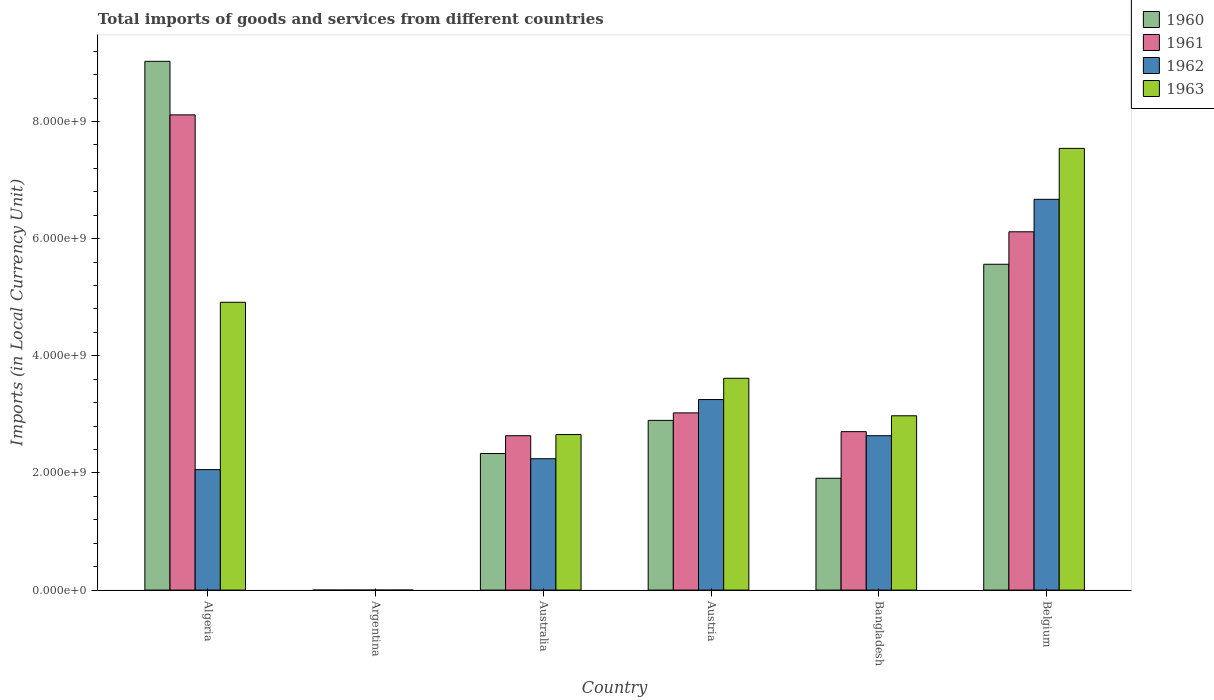How many different coloured bars are there?
Ensure brevity in your answer.  4. Are the number of bars per tick equal to the number of legend labels?
Provide a succinct answer. Yes. Are the number of bars on each tick of the X-axis equal?
Your response must be concise. Yes. How many bars are there on the 5th tick from the left?
Make the answer very short. 4. What is the label of the 3rd group of bars from the left?
Your answer should be compact. Australia. In how many cases, is the number of bars for a given country not equal to the number of legend labels?
Make the answer very short. 0. What is the Amount of goods and services imports in 1960 in Australia?
Offer a terse response. 2.33e+09. Across all countries, what is the maximum Amount of goods and services imports in 1961?
Ensure brevity in your answer.  8.11e+09. Across all countries, what is the minimum Amount of goods and services imports in 1960?
Provide a succinct answer. 0.01. In which country was the Amount of goods and services imports in 1960 maximum?
Ensure brevity in your answer.  Algeria. What is the total Amount of goods and services imports in 1963 in the graph?
Provide a succinct answer. 2.17e+1. What is the difference between the Amount of goods and services imports in 1962 in Argentina and that in Australia?
Your response must be concise. -2.24e+09. What is the difference between the Amount of goods and services imports in 1963 in Belgium and the Amount of goods and services imports in 1962 in Argentina?
Give a very brief answer. 7.54e+09. What is the average Amount of goods and services imports in 1960 per country?
Your answer should be compact. 3.62e+09. What is the difference between the Amount of goods and services imports of/in 1961 and Amount of goods and services imports of/in 1963 in Belgium?
Offer a terse response. -1.42e+09. What is the ratio of the Amount of goods and services imports in 1963 in Argentina to that in Australia?
Your answer should be very brief. 7.530120331325301e-12. What is the difference between the highest and the second highest Amount of goods and services imports in 1961?
Provide a succinct answer. 2.00e+09. What is the difference between the highest and the lowest Amount of goods and services imports in 1963?
Ensure brevity in your answer.  7.54e+09. In how many countries, is the Amount of goods and services imports in 1960 greater than the average Amount of goods and services imports in 1960 taken over all countries?
Your answer should be very brief. 2. Is it the case that in every country, the sum of the Amount of goods and services imports in 1963 and Amount of goods and services imports in 1961 is greater than the sum of Amount of goods and services imports in 1962 and Amount of goods and services imports in 1960?
Your answer should be very brief. No. What does the 3rd bar from the left in Australia represents?
Make the answer very short. 1962. How many bars are there?
Your response must be concise. 24. How many countries are there in the graph?
Provide a succinct answer. 6. What is the difference between two consecutive major ticks on the Y-axis?
Ensure brevity in your answer.  2.00e+09. Does the graph contain grids?
Your answer should be very brief. No. How many legend labels are there?
Offer a terse response. 4. How are the legend labels stacked?
Provide a succinct answer. Vertical. What is the title of the graph?
Your answer should be compact. Total imports of goods and services from different countries. Does "1996" appear as one of the legend labels in the graph?
Your answer should be very brief. No. What is the label or title of the X-axis?
Provide a short and direct response. Country. What is the label or title of the Y-axis?
Your response must be concise. Imports (in Local Currency Unit). What is the Imports (in Local Currency Unit) in 1960 in Algeria?
Offer a very short reply. 9.03e+09. What is the Imports (in Local Currency Unit) in 1961 in Algeria?
Provide a succinct answer. 8.11e+09. What is the Imports (in Local Currency Unit) of 1962 in Algeria?
Keep it short and to the point. 2.06e+09. What is the Imports (in Local Currency Unit) of 1963 in Algeria?
Keep it short and to the point. 4.91e+09. What is the Imports (in Local Currency Unit) in 1960 in Argentina?
Give a very brief answer. 0.01. What is the Imports (in Local Currency Unit) of 1961 in Argentina?
Provide a succinct answer. 0.01. What is the Imports (in Local Currency Unit) of 1962 in Argentina?
Keep it short and to the point. 0.02. What is the Imports (in Local Currency Unit) of 1963 in Argentina?
Keep it short and to the point. 0.02. What is the Imports (in Local Currency Unit) in 1960 in Australia?
Your answer should be compact. 2.33e+09. What is the Imports (in Local Currency Unit) in 1961 in Australia?
Make the answer very short. 2.64e+09. What is the Imports (in Local Currency Unit) in 1962 in Australia?
Give a very brief answer. 2.24e+09. What is the Imports (in Local Currency Unit) of 1963 in Australia?
Keep it short and to the point. 2.66e+09. What is the Imports (in Local Currency Unit) in 1960 in Austria?
Give a very brief answer. 2.90e+09. What is the Imports (in Local Currency Unit) of 1961 in Austria?
Your answer should be very brief. 3.03e+09. What is the Imports (in Local Currency Unit) of 1962 in Austria?
Your answer should be very brief. 3.25e+09. What is the Imports (in Local Currency Unit) of 1963 in Austria?
Your answer should be very brief. 3.62e+09. What is the Imports (in Local Currency Unit) in 1960 in Bangladesh?
Give a very brief answer. 1.91e+09. What is the Imports (in Local Currency Unit) in 1961 in Bangladesh?
Your response must be concise. 2.71e+09. What is the Imports (in Local Currency Unit) of 1962 in Bangladesh?
Provide a short and direct response. 2.64e+09. What is the Imports (in Local Currency Unit) in 1963 in Bangladesh?
Make the answer very short. 2.98e+09. What is the Imports (in Local Currency Unit) of 1960 in Belgium?
Make the answer very short. 5.56e+09. What is the Imports (in Local Currency Unit) in 1961 in Belgium?
Provide a short and direct response. 6.12e+09. What is the Imports (in Local Currency Unit) in 1962 in Belgium?
Offer a very short reply. 6.67e+09. What is the Imports (in Local Currency Unit) of 1963 in Belgium?
Ensure brevity in your answer.  7.54e+09. Across all countries, what is the maximum Imports (in Local Currency Unit) in 1960?
Keep it short and to the point. 9.03e+09. Across all countries, what is the maximum Imports (in Local Currency Unit) in 1961?
Offer a terse response. 8.11e+09. Across all countries, what is the maximum Imports (in Local Currency Unit) in 1962?
Your response must be concise. 6.67e+09. Across all countries, what is the maximum Imports (in Local Currency Unit) in 1963?
Keep it short and to the point. 7.54e+09. Across all countries, what is the minimum Imports (in Local Currency Unit) of 1960?
Make the answer very short. 0.01. Across all countries, what is the minimum Imports (in Local Currency Unit) of 1961?
Provide a short and direct response. 0.01. Across all countries, what is the minimum Imports (in Local Currency Unit) in 1962?
Offer a very short reply. 0.02. Across all countries, what is the minimum Imports (in Local Currency Unit) in 1963?
Provide a short and direct response. 0.02. What is the total Imports (in Local Currency Unit) in 1960 in the graph?
Provide a succinct answer. 2.17e+1. What is the total Imports (in Local Currency Unit) of 1961 in the graph?
Offer a terse response. 2.26e+1. What is the total Imports (in Local Currency Unit) of 1962 in the graph?
Give a very brief answer. 1.69e+1. What is the total Imports (in Local Currency Unit) of 1963 in the graph?
Make the answer very short. 2.17e+1. What is the difference between the Imports (in Local Currency Unit) in 1960 in Algeria and that in Argentina?
Keep it short and to the point. 9.03e+09. What is the difference between the Imports (in Local Currency Unit) of 1961 in Algeria and that in Argentina?
Offer a terse response. 8.11e+09. What is the difference between the Imports (in Local Currency Unit) of 1962 in Algeria and that in Argentina?
Provide a succinct answer. 2.06e+09. What is the difference between the Imports (in Local Currency Unit) of 1963 in Algeria and that in Argentina?
Offer a terse response. 4.91e+09. What is the difference between the Imports (in Local Currency Unit) of 1960 in Algeria and that in Australia?
Offer a terse response. 6.70e+09. What is the difference between the Imports (in Local Currency Unit) in 1961 in Algeria and that in Australia?
Your response must be concise. 5.48e+09. What is the difference between the Imports (in Local Currency Unit) of 1962 in Algeria and that in Australia?
Provide a short and direct response. -1.86e+08. What is the difference between the Imports (in Local Currency Unit) in 1963 in Algeria and that in Australia?
Make the answer very short. 2.26e+09. What is the difference between the Imports (in Local Currency Unit) in 1960 in Algeria and that in Austria?
Keep it short and to the point. 6.13e+09. What is the difference between the Imports (in Local Currency Unit) of 1961 in Algeria and that in Austria?
Make the answer very short. 5.09e+09. What is the difference between the Imports (in Local Currency Unit) in 1962 in Algeria and that in Austria?
Keep it short and to the point. -1.20e+09. What is the difference between the Imports (in Local Currency Unit) in 1963 in Algeria and that in Austria?
Make the answer very short. 1.30e+09. What is the difference between the Imports (in Local Currency Unit) in 1960 in Algeria and that in Bangladesh?
Provide a succinct answer. 7.12e+09. What is the difference between the Imports (in Local Currency Unit) in 1961 in Algeria and that in Bangladesh?
Provide a succinct answer. 5.41e+09. What is the difference between the Imports (in Local Currency Unit) of 1962 in Algeria and that in Bangladesh?
Make the answer very short. -5.79e+08. What is the difference between the Imports (in Local Currency Unit) in 1963 in Algeria and that in Bangladesh?
Your answer should be very brief. 1.94e+09. What is the difference between the Imports (in Local Currency Unit) of 1960 in Algeria and that in Belgium?
Ensure brevity in your answer.  3.46e+09. What is the difference between the Imports (in Local Currency Unit) of 1961 in Algeria and that in Belgium?
Offer a very short reply. 2.00e+09. What is the difference between the Imports (in Local Currency Unit) in 1962 in Algeria and that in Belgium?
Your answer should be compact. -4.62e+09. What is the difference between the Imports (in Local Currency Unit) in 1963 in Algeria and that in Belgium?
Provide a short and direct response. -2.63e+09. What is the difference between the Imports (in Local Currency Unit) of 1960 in Argentina and that in Australia?
Ensure brevity in your answer.  -2.33e+09. What is the difference between the Imports (in Local Currency Unit) of 1961 in Argentina and that in Australia?
Your response must be concise. -2.64e+09. What is the difference between the Imports (in Local Currency Unit) in 1962 in Argentina and that in Australia?
Offer a terse response. -2.24e+09. What is the difference between the Imports (in Local Currency Unit) of 1963 in Argentina and that in Australia?
Your answer should be compact. -2.66e+09. What is the difference between the Imports (in Local Currency Unit) of 1960 in Argentina and that in Austria?
Your answer should be compact. -2.90e+09. What is the difference between the Imports (in Local Currency Unit) of 1961 in Argentina and that in Austria?
Give a very brief answer. -3.03e+09. What is the difference between the Imports (in Local Currency Unit) of 1962 in Argentina and that in Austria?
Your response must be concise. -3.25e+09. What is the difference between the Imports (in Local Currency Unit) in 1963 in Argentina and that in Austria?
Provide a short and direct response. -3.62e+09. What is the difference between the Imports (in Local Currency Unit) in 1960 in Argentina and that in Bangladesh?
Provide a succinct answer. -1.91e+09. What is the difference between the Imports (in Local Currency Unit) in 1961 in Argentina and that in Bangladesh?
Offer a very short reply. -2.71e+09. What is the difference between the Imports (in Local Currency Unit) in 1962 in Argentina and that in Bangladesh?
Provide a succinct answer. -2.64e+09. What is the difference between the Imports (in Local Currency Unit) in 1963 in Argentina and that in Bangladesh?
Provide a succinct answer. -2.98e+09. What is the difference between the Imports (in Local Currency Unit) of 1960 in Argentina and that in Belgium?
Ensure brevity in your answer.  -5.56e+09. What is the difference between the Imports (in Local Currency Unit) in 1961 in Argentina and that in Belgium?
Your answer should be compact. -6.12e+09. What is the difference between the Imports (in Local Currency Unit) in 1962 in Argentina and that in Belgium?
Your answer should be very brief. -6.67e+09. What is the difference between the Imports (in Local Currency Unit) of 1963 in Argentina and that in Belgium?
Your response must be concise. -7.54e+09. What is the difference between the Imports (in Local Currency Unit) in 1960 in Australia and that in Austria?
Offer a terse response. -5.66e+08. What is the difference between the Imports (in Local Currency Unit) of 1961 in Australia and that in Austria?
Your answer should be compact. -3.90e+08. What is the difference between the Imports (in Local Currency Unit) of 1962 in Australia and that in Austria?
Your response must be concise. -1.01e+09. What is the difference between the Imports (in Local Currency Unit) of 1963 in Australia and that in Austria?
Give a very brief answer. -9.61e+08. What is the difference between the Imports (in Local Currency Unit) in 1960 in Australia and that in Bangladesh?
Provide a succinct answer. 4.22e+08. What is the difference between the Imports (in Local Currency Unit) in 1961 in Australia and that in Bangladesh?
Provide a short and direct response. -6.96e+07. What is the difference between the Imports (in Local Currency Unit) of 1962 in Australia and that in Bangladesh?
Offer a terse response. -3.93e+08. What is the difference between the Imports (in Local Currency Unit) in 1963 in Australia and that in Bangladesh?
Provide a succinct answer. -3.20e+08. What is the difference between the Imports (in Local Currency Unit) in 1960 in Australia and that in Belgium?
Ensure brevity in your answer.  -3.23e+09. What is the difference between the Imports (in Local Currency Unit) in 1961 in Australia and that in Belgium?
Your answer should be very brief. -3.48e+09. What is the difference between the Imports (in Local Currency Unit) of 1962 in Australia and that in Belgium?
Give a very brief answer. -4.43e+09. What is the difference between the Imports (in Local Currency Unit) in 1963 in Australia and that in Belgium?
Your response must be concise. -4.89e+09. What is the difference between the Imports (in Local Currency Unit) of 1960 in Austria and that in Bangladesh?
Your answer should be compact. 9.88e+08. What is the difference between the Imports (in Local Currency Unit) in 1961 in Austria and that in Bangladesh?
Your answer should be compact. 3.20e+08. What is the difference between the Imports (in Local Currency Unit) in 1962 in Austria and that in Bangladesh?
Your answer should be compact. 6.18e+08. What is the difference between the Imports (in Local Currency Unit) of 1963 in Austria and that in Bangladesh?
Offer a very short reply. 6.41e+08. What is the difference between the Imports (in Local Currency Unit) in 1960 in Austria and that in Belgium?
Offer a terse response. -2.67e+09. What is the difference between the Imports (in Local Currency Unit) of 1961 in Austria and that in Belgium?
Your response must be concise. -3.09e+09. What is the difference between the Imports (in Local Currency Unit) of 1962 in Austria and that in Belgium?
Provide a succinct answer. -3.42e+09. What is the difference between the Imports (in Local Currency Unit) in 1963 in Austria and that in Belgium?
Your answer should be very brief. -3.93e+09. What is the difference between the Imports (in Local Currency Unit) in 1960 in Bangladesh and that in Belgium?
Provide a short and direct response. -3.65e+09. What is the difference between the Imports (in Local Currency Unit) in 1961 in Bangladesh and that in Belgium?
Offer a terse response. -3.41e+09. What is the difference between the Imports (in Local Currency Unit) of 1962 in Bangladesh and that in Belgium?
Offer a very short reply. -4.04e+09. What is the difference between the Imports (in Local Currency Unit) of 1963 in Bangladesh and that in Belgium?
Your response must be concise. -4.57e+09. What is the difference between the Imports (in Local Currency Unit) of 1960 in Algeria and the Imports (in Local Currency Unit) of 1961 in Argentina?
Provide a short and direct response. 9.03e+09. What is the difference between the Imports (in Local Currency Unit) in 1960 in Algeria and the Imports (in Local Currency Unit) in 1962 in Argentina?
Provide a succinct answer. 9.03e+09. What is the difference between the Imports (in Local Currency Unit) of 1960 in Algeria and the Imports (in Local Currency Unit) of 1963 in Argentina?
Your answer should be compact. 9.03e+09. What is the difference between the Imports (in Local Currency Unit) of 1961 in Algeria and the Imports (in Local Currency Unit) of 1962 in Argentina?
Give a very brief answer. 8.11e+09. What is the difference between the Imports (in Local Currency Unit) in 1961 in Algeria and the Imports (in Local Currency Unit) in 1963 in Argentina?
Your answer should be very brief. 8.11e+09. What is the difference between the Imports (in Local Currency Unit) in 1962 in Algeria and the Imports (in Local Currency Unit) in 1963 in Argentina?
Provide a short and direct response. 2.06e+09. What is the difference between the Imports (in Local Currency Unit) in 1960 in Algeria and the Imports (in Local Currency Unit) in 1961 in Australia?
Your answer should be very brief. 6.39e+09. What is the difference between the Imports (in Local Currency Unit) of 1960 in Algeria and the Imports (in Local Currency Unit) of 1962 in Australia?
Your response must be concise. 6.79e+09. What is the difference between the Imports (in Local Currency Unit) in 1960 in Algeria and the Imports (in Local Currency Unit) in 1963 in Australia?
Provide a succinct answer. 6.37e+09. What is the difference between the Imports (in Local Currency Unit) of 1961 in Algeria and the Imports (in Local Currency Unit) of 1962 in Australia?
Your answer should be compact. 5.87e+09. What is the difference between the Imports (in Local Currency Unit) of 1961 in Algeria and the Imports (in Local Currency Unit) of 1963 in Australia?
Your response must be concise. 5.46e+09. What is the difference between the Imports (in Local Currency Unit) of 1962 in Algeria and the Imports (in Local Currency Unit) of 1963 in Australia?
Offer a terse response. -5.99e+08. What is the difference between the Imports (in Local Currency Unit) in 1960 in Algeria and the Imports (in Local Currency Unit) in 1961 in Austria?
Ensure brevity in your answer.  6.00e+09. What is the difference between the Imports (in Local Currency Unit) in 1960 in Algeria and the Imports (in Local Currency Unit) in 1962 in Austria?
Ensure brevity in your answer.  5.77e+09. What is the difference between the Imports (in Local Currency Unit) of 1960 in Algeria and the Imports (in Local Currency Unit) of 1963 in Austria?
Provide a short and direct response. 5.41e+09. What is the difference between the Imports (in Local Currency Unit) of 1961 in Algeria and the Imports (in Local Currency Unit) of 1962 in Austria?
Offer a very short reply. 4.86e+09. What is the difference between the Imports (in Local Currency Unit) of 1961 in Algeria and the Imports (in Local Currency Unit) of 1963 in Austria?
Offer a very short reply. 4.50e+09. What is the difference between the Imports (in Local Currency Unit) of 1962 in Algeria and the Imports (in Local Currency Unit) of 1963 in Austria?
Give a very brief answer. -1.56e+09. What is the difference between the Imports (in Local Currency Unit) of 1960 in Algeria and the Imports (in Local Currency Unit) of 1961 in Bangladesh?
Your answer should be very brief. 6.32e+09. What is the difference between the Imports (in Local Currency Unit) in 1960 in Algeria and the Imports (in Local Currency Unit) in 1962 in Bangladesh?
Keep it short and to the point. 6.39e+09. What is the difference between the Imports (in Local Currency Unit) of 1960 in Algeria and the Imports (in Local Currency Unit) of 1963 in Bangladesh?
Provide a succinct answer. 6.05e+09. What is the difference between the Imports (in Local Currency Unit) in 1961 in Algeria and the Imports (in Local Currency Unit) in 1962 in Bangladesh?
Offer a terse response. 5.48e+09. What is the difference between the Imports (in Local Currency Unit) of 1961 in Algeria and the Imports (in Local Currency Unit) of 1963 in Bangladesh?
Your response must be concise. 5.14e+09. What is the difference between the Imports (in Local Currency Unit) of 1962 in Algeria and the Imports (in Local Currency Unit) of 1963 in Bangladesh?
Give a very brief answer. -9.19e+08. What is the difference between the Imports (in Local Currency Unit) of 1960 in Algeria and the Imports (in Local Currency Unit) of 1961 in Belgium?
Provide a short and direct response. 2.91e+09. What is the difference between the Imports (in Local Currency Unit) in 1960 in Algeria and the Imports (in Local Currency Unit) in 1962 in Belgium?
Keep it short and to the point. 2.36e+09. What is the difference between the Imports (in Local Currency Unit) in 1960 in Algeria and the Imports (in Local Currency Unit) in 1963 in Belgium?
Keep it short and to the point. 1.49e+09. What is the difference between the Imports (in Local Currency Unit) in 1961 in Algeria and the Imports (in Local Currency Unit) in 1962 in Belgium?
Give a very brief answer. 1.44e+09. What is the difference between the Imports (in Local Currency Unit) in 1961 in Algeria and the Imports (in Local Currency Unit) in 1963 in Belgium?
Your response must be concise. 5.72e+08. What is the difference between the Imports (in Local Currency Unit) of 1962 in Algeria and the Imports (in Local Currency Unit) of 1963 in Belgium?
Your answer should be very brief. -5.48e+09. What is the difference between the Imports (in Local Currency Unit) in 1960 in Argentina and the Imports (in Local Currency Unit) in 1961 in Australia?
Ensure brevity in your answer.  -2.64e+09. What is the difference between the Imports (in Local Currency Unit) in 1960 in Argentina and the Imports (in Local Currency Unit) in 1962 in Australia?
Your answer should be very brief. -2.24e+09. What is the difference between the Imports (in Local Currency Unit) of 1960 in Argentina and the Imports (in Local Currency Unit) of 1963 in Australia?
Your response must be concise. -2.66e+09. What is the difference between the Imports (in Local Currency Unit) of 1961 in Argentina and the Imports (in Local Currency Unit) of 1962 in Australia?
Your response must be concise. -2.24e+09. What is the difference between the Imports (in Local Currency Unit) of 1961 in Argentina and the Imports (in Local Currency Unit) of 1963 in Australia?
Your answer should be very brief. -2.66e+09. What is the difference between the Imports (in Local Currency Unit) in 1962 in Argentina and the Imports (in Local Currency Unit) in 1963 in Australia?
Ensure brevity in your answer.  -2.66e+09. What is the difference between the Imports (in Local Currency Unit) in 1960 in Argentina and the Imports (in Local Currency Unit) in 1961 in Austria?
Your answer should be compact. -3.03e+09. What is the difference between the Imports (in Local Currency Unit) in 1960 in Argentina and the Imports (in Local Currency Unit) in 1962 in Austria?
Offer a terse response. -3.25e+09. What is the difference between the Imports (in Local Currency Unit) in 1960 in Argentina and the Imports (in Local Currency Unit) in 1963 in Austria?
Offer a terse response. -3.62e+09. What is the difference between the Imports (in Local Currency Unit) in 1961 in Argentina and the Imports (in Local Currency Unit) in 1962 in Austria?
Your answer should be very brief. -3.25e+09. What is the difference between the Imports (in Local Currency Unit) in 1961 in Argentina and the Imports (in Local Currency Unit) in 1963 in Austria?
Ensure brevity in your answer.  -3.62e+09. What is the difference between the Imports (in Local Currency Unit) of 1962 in Argentina and the Imports (in Local Currency Unit) of 1963 in Austria?
Give a very brief answer. -3.62e+09. What is the difference between the Imports (in Local Currency Unit) of 1960 in Argentina and the Imports (in Local Currency Unit) of 1961 in Bangladesh?
Your answer should be very brief. -2.71e+09. What is the difference between the Imports (in Local Currency Unit) of 1960 in Argentina and the Imports (in Local Currency Unit) of 1962 in Bangladesh?
Keep it short and to the point. -2.64e+09. What is the difference between the Imports (in Local Currency Unit) in 1960 in Argentina and the Imports (in Local Currency Unit) in 1963 in Bangladesh?
Provide a succinct answer. -2.98e+09. What is the difference between the Imports (in Local Currency Unit) in 1961 in Argentina and the Imports (in Local Currency Unit) in 1962 in Bangladesh?
Provide a succinct answer. -2.64e+09. What is the difference between the Imports (in Local Currency Unit) in 1961 in Argentina and the Imports (in Local Currency Unit) in 1963 in Bangladesh?
Your answer should be very brief. -2.98e+09. What is the difference between the Imports (in Local Currency Unit) of 1962 in Argentina and the Imports (in Local Currency Unit) of 1963 in Bangladesh?
Offer a terse response. -2.98e+09. What is the difference between the Imports (in Local Currency Unit) in 1960 in Argentina and the Imports (in Local Currency Unit) in 1961 in Belgium?
Provide a succinct answer. -6.12e+09. What is the difference between the Imports (in Local Currency Unit) in 1960 in Argentina and the Imports (in Local Currency Unit) in 1962 in Belgium?
Give a very brief answer. -6.67e+09. What is the difference between the Imports (in Local Currency Unit) of 1960 in Argentina and the Imports (in Local Currency Unit) of 1963 in Belgium?
Keep it short and to the point. -7.54e+09. What is the difference between the Imports (in Local Currency Unit) of 1961 in Argentina and the Imports (in Local Currency Unit) of 1962 in Belgium?
Your answer should be very brief. -6.67e+09. What is the difference between the Imports (in Local Currency Unit) in 1961 in Argentina and the Imports (in Local Currency Unit) in 1963 in Belgium?
Offer a very short reply. -7.54e+09. What is the difference between the Imports (in Local Currency Unit) of 1962 in Argentina and the Imports (in Local Currency Unit) of 1963 in Belgium?
Make the answer very short. -7.54e+09. What is the difference between the Imports (in Local Currency Unit) in 1960 in Australia and the Imports (in Local Currency Unit) in 1961 in Austria?
Ensure brevity in your answer.  -6.94e+08. What is the difference between the Imports (in Local Currency Unit) in 1960 in Australia and the Imports (in Local Currency Unit) in 1962 in Austria?
Keep it short and to the point. -9.22e+08. What is the difference between the Imports (in Local Currency Unit) in 1960 in Australia and the Imports (in Local Currency Unit) in 1963 in Austria?
Ensure brevity in your answer.  -1.28e+09. What is the difference between the Imports (in Local Currency Unit) in 1961 in Australia and the Imports (in Local Currency Unit) in 1962 in Austria?
Keep it short and to the point. -6.18e+08. What is the difference between the Imports (in Local Currency Unit) in 1961 in Australia and the Imports (in Local Currency Unit) in 1963 in Austria?
Keep it short and to the point. -9.81e+08. What is the difference between the Imports (in Local Currency Unit) in 1962 in Australia and the Imports (in Local Currency Unit) in 1963 in Austria?
Keep it short and to the point. -1.37e+09. What is the difference between the Imports (in Local Currency Unit) of 1960 in Australia and the Imports (in Local Currency Unit) of 1961 in Bangladesh?
Your response must be concise. -3.74e+08. What is the difference between the Imports (in Local Currency Unit) of 1960 in Australia and the Imports (in Local Currency Unit) of 1962 in Bangladesh?
Give a very brief answer. -3.04e+08. What is the difference between the Imports (in Local Currency Unit) of 1960 in Australia and the Imports (in Local Currency Unit) of 1963 in Bangladesh?
Make the answer very short. -6.44e+08. What is the difference between the Imports (in Local Currency Unit) in 1961 in Australia and the Imports (in Local Currency Unit) in 1962 in Bangladesh?
Make the answer very short. -1.80e+05. What is the difference between the Imports (in Local Currency Unit) in 1961 in Australia and the Imports (in Local Currency Unit) in 1963 in Bangladesh?
Keep it short and to the point. -3.40e+08. What is the difference between the Imports (in Local Currency Unit) of 1962 in Australia and the Imports (in Local Currency Unit) of 1963 in Bangladesh?
Offer a terse response. -7.33e+08. What is the difference between the Imports (in Local Currency Unit) in 1960 in Australia and the Imports (in Local Currency Unit) in 1961 in Belgium?
Give a very brief answer. -3.79e+09. What is the difference between the Imports (in Local Currency Unit) in 1960 in Australia and the Imports (in Local Currency Unit) in 1962 in Belgium?
Provide a succinct answer. -4.34e+09. What is the difference between the Imports (in Local Currency Unit) of 1960 in Australia and the Imports (in Local Currency Unit) of 1963 in Belgium?
Keep it short and to the point. -5.21e+09. What is the difference between the Imports (in Local Currency Unit) of 1961 in Australia and the Imports (in Local Currency Unit) of 1962 in Belgium?
Your answer should be very brief. -4.04e+09. What is the difference between the Imports (in Local Currency Unit) of 1961 in Australia and the Imports (in Local Currency Unit) of 1963 in Belgium?
Ensure brevity in your answer.  -4.91e+09. What is the difference between the Imports (in Local Currency Unit) of 1962 in Australia and the Imports (in Local Currency Unit) of 1963 in Belgium?
Offer a terse response. -5.30e+09. What is the difference between the Imports (in Local Currency Unit) in 1960 in Austria and the Imports (in Local Currency Unit) in 1961 in Bangladesh?
Provide a short and direct response. 1.92e+08. What is the difference between the Imports (in Local Currency Unit) in 1960 in Austria and the Imports (in Local Currency Unit) in 1962 in Bangladesh?
Offer a very short reply. 2.62e+08. What is the difference between the Imports (in Local Currency Unit) of 1960 in Austria and the Imports (in Local Currency Unit) of 1963 in Bangladesh?
Make the answer very short. -7.85e+07. What is the difference between the Imports (in Local Currency Unit) in 1961 in Austria and the Imports (in Local Currency Unit) in 1962 in Bangladesh?
Keep it short and to the point. 3.90e+08. What is the difference between the Imports (in Local Currency Unit) in 1961 in Austria and the Imports (in Local Currency Unit) in 1963 in Bangladesh?
Keep it short and to the point. 4.96e+07. What is the difference between the Imports (in Local Currency Unit) of 1962 in Austria and the Imports (in Local Currency Unit) of 1963 in Bangladesh?
Keep it short and to the point. 2.77e+08. What is the difference between the Imports (in Local Currency Unit) of 1960 in Austria and the Imports (in Local Currency Unit) of 1961 in Belgium?
Your answer should be compact. -3.22e+09. What is the difference between the Imports (in Local Currency Unit) of 1960 in Austria and the Imports (in Local Currency Unit) of 1962 in Belgium?
Provide a short and direct response. -3.77e+09. What is the difference between the Imports (in Local Currency Unit) of 1960 in Austria and the Imports (in Local Currency Unit) of 1963 in Belgium?
Your answer should be compact. -4.64e+09. What is the difference between the Imports (in Local Currency Unit) in 1961 in Austria and the Imports (in Local Currency Unit) in 1962 in Belgium?
Keep it short and to the point. -3.65e+09. What is the difference between the Imports (in Local Currency Unit) of 1961 in Austria and the Imports (in Local Currency Unit) of 1963 in Belgium?
Offer a terse response. -4.52e+09. What is the difference between the Imports (in Local Currency Unit) of 1962 in Austria and the Imports (in Local Currency Unit) of 1963 in Belgium?
Your response must be concise. -4.29e+09. What is the difference between the Imports (in Local Currency Unit) of 1960 in Bangladesh and the Imports (in Local Currency Unit) of 1961 in Belgium?
Your answer should be compact. -4.21e+09. What is the difference between the Imports (in Local Currency Unit) of 1960 in Bangladesh and the Imports (in Local Currency Unit) of 1962 in Belgium?
Your answer should be very brief. -4.76e+09. What is the difference between the Imports (in Local Currency Unit) of 1960 in Bangladesh and the Imports (in Local Currency Unit) of 1963 in Belgium?
Your answer should be compact. -5.63e+09. What is the difference between the Imports (in Local Currency Unit) in 1961 in Bangladesh and the Imports (in Local Currency Unit) in 1962 in Belgium?
Offer a very short reply. -3.97e+09. What is the difference between the Imports (in Local Currency Unit) of 1961 in Bangladesh and the Imports (in Local Currency Unit) of 1963 in Belgium?
Offer a very short reply. -4.84e+09. What is the difference between the Imports (in Local Currency Unit) of 1962 in Bangladesh and the Imports (in Local Currency Unit) of 1963 in Belgium?
Provide a short and direct response. -4.91e+09. What is the average Imports (in Local Currency Unit) in 1960 per country?
Offer a terse response. 3.62e+09. What is the average Imports (in Local Currency Unit) in 1961 per country?
Provide a succinct answer. 3.77e+09. What is the average Imports (in Local Currency Unit) of 1962 per country?
Your response must be concise. 2.81e+09. What is the average Imports (in Local Currency Unit) in 1963 per country?
Your answer should be very brief. 3.62e+09. What is the difference between the Imports (in Local Currency Unit) in 1960 and Imports (in Local Currency Unit) in 1961 in Algeria?
Provide a short and direct response. 9.14e+08. What is the difference between the Imports (in Local Currency Unit) of 1960 and Imports (in Local Currency Unit) of 1962 in Algeria?
Your answer should be very brief. 6.97e+09. What is the difference between the Imports (in Local Currency Unit) of 1960 and Imports (in Local Currency Unit) of 1963 in Algeria?
Give a very brief answer. 4.11e+09. What is the difference between the Imports (in Local Currency Unit) in 1961 and Imports (in Local Currency Unit) in 1962 in Algeria?
Your response must be concise. 6.06e+09. What is the difference between the Imports (in Local Currency Unit) in 1961 and Imports (in Local Currency Unit) in 1963 in Algeria?
Your response must be concise. 3.20e+09. What is the difference between the Imports (in Local Currency Unit) of 1962 and Imports (in Local Currency Unit) of 1963 in Algeria?
Keep it short and to the point. -2.86e+09. What is the difference between the Imports (in Local Currency Unit) of 1960 and Imports (in Local Currency Unit) of 1961 in Argentina?
Provide a succinct answer. 0. What is the difference between the Imports (in Local Currency Unit) in 1960 and Imports (in Local Currency Unit) in 1962 in Argentina?
Offer a very short reply. -0.01. What is the difference between the Imports (in Local Currency Unit) of 1960 and Imports (in Local Currency Unit) of 1963 in Argentina?
Your answer should be very brief. -0.01. What is the difference between the Imports (in Local Currency Unit) of 1961 and Imports (in Local Currency Unit) of 1962 in Argentina?
Make the answer very short. -0.01. What is the difference between the Imports (in Local Currency Unit) of 1961 and Imports (in Local Currency Unit) of 1963 in Argentina?
Offer a very short reply. -0.01. What is the difference between the Imports (in Local Currency Unit) in 1962 and Imports (in Local Currency Unit) in 1963 in Argentina?
Offer a terse response. 0. What is the difference between the Imports (in Local Currency Unit) in 1960 and Imports (in Local Currency Unit) in 1961 in Australia?
Provide a succinct answer. -3.04e+08. What is the difference between the Imports (in Local Currency Unit) of 1960 and Imports (in Local Currency Unit) of 1962 in Australia?
Your answer should be very brief. 8.90e+07. What is the difference between the Imports (in Local Currency Unit) of 1960 and Imports (in Local Currency Unit) of 1963 in Australia?
Ensure brevity in your answer.  -3.24e+08. What is the difference between the Imports (in Local Currency Unit) in 1961 and Imports (in Local Currency Unit) in 1962 in Australia?
Offer a terse response. 3.93e+08. What is the difference between the Imports (in Local Currency Unit) of 1961 and Imports (in Local Currency Unit) of 1963 in Australia?
Your response must be concise. -2.00e+07. What is the difference between the Imports (in Local Currency Unit) of 1962 and Imports (in Local Currency Unit) of 1963 in Australia?
Provide a succinct answer. -4.13e+08. What is the difference between the Imports (in Local Currency Unit) in 1960 and Imports (in Local Currency Unit) in 1961 in Austria?
Offer a terse response. -1.28e+08. What is the difference between the Imports (in Local Currency Unit) of 1960 and Imports (in Local Currency Unit) of 1962 in Austria?
Your response must be concise. -3.56e+08. What is the difference between the Imports (in Local Currency Unit) in 1960 and Imports (in Local Currency Unit) in 1963 in Austria?
Ensure brevity in your answer.  -7.19e+08. What is the difference between the Imports (in Local Currency Unit) of 1961 and Imports (in Local Currency Unit) of 1962 in Austria?
Your answer should be compact. -2.28e+08. What is the difference between the Imports (in Local Currency Unit) of 1961 and Imports (in Local Currency Unit) of 1963 in Austria?
Your answer should be very brief. -5.91e+08. What is the difference between the Imports (in Local Currency Unit) of 1962 and Imports (in Local Currency Unit) of 1963 in Austria?
Ensure brevity in your answer.  -3.63e+08. What is the difference between the Imports (in Local Currency Unit) of 1960 and Imports (in Local Currency Unit) of 1961 in Bangladesh?
Make the answer very short. -7.96e+08. What is the difference between the Imports (in Local Currency Unit) of 1960 and Imports (in Local Currency Unit) of 1962 in Bangladesh?
Provide a succinct answer. -7.26e+08. What is the difference between the Imports (in Local Currency Unit) of 1960 and Imports (in Local Currency Unit) of 1963 in Bangladesh?
Make the answer very short. -1.07e+09. What is the difference between the Imports (in Local Currency Unit) of 1961 and Imports (in Local Currency Unit) of 1962 in Bangladesh?
Provide a succinct answer. 6.94e+07. What is the difference between the Imports (in Local Currency Unit) in 1961 and Imports (in Local Currency Unit) in 1963 in Bangladesh?
Provide a short and direct response. -2.71e+08. What is the difference between the Imports (in Local Currency Unit) in 1962 and Imports (in Local Currency Unit) in 1963 in Bangladesh?
Your response must be concise. -3.40e+08. What is the difference between the Imports (in Local Currency Unit) of 1960 and Imports (in Local Currency Unit) of 1961 in Belgium?
Keep it short and to the point. -5.54e+08. What is the difference between the Imports (in Local Currency Unit) of 1960 and Imports (in Local Currency Unit) of 1962 in Belgium?
Provide a short and direct response. -1.11e+09. What is the difference between the Imports (in Local Currency Unit) of 1960 and Imports (in Local Currency Unit) of 1963 in Belgium?
Your answer should be compact. -1.98e+09. What is the difference between the Imports (in Local Currency Unit) of 1961 and Imports (in Local Currency Unit) of 1962 in Belgium?
Ensure brevity in your answer.  -5.54e+08. What is the difference between the Imports (in Local Currency Unit) of 1961 and Imports (in Local Currency Unit) of 1963 in Belgium?
Your answer should be very brief. -1.42e+09. What is the difference between the Imports (in Local Currency Unit) in 1962 and Imports (in Local Currency Unit) in 1963 in Belgium?
Your answer should be compact. -8.70e+08. What is the ratio of the Imports (in Local Currency Unit) in 1960 in Algeria to that in Argentina?
Provide a succinct answer. 9.03e+11. What is the ratio of the Imports (in Local Currency Unit) of 1961 in Algeria to that in Argentina?
Your response must be concise. 8.11e+11. What is the ratio of the Imports (in Local Currency Unit) of 1962 in Algeria to that in Argentina?
Offer a terse response. 1.03e+11. What is the ratio of the Imports (in Local Currency Unit) of 1963 in Algeria to that in Argentina?
Give a very brief answer. 2.46e+11. What is the ratio of the Imports (in Local Currency Unit) of 1960 in Algeria to that in Australia?
Offer a very short reply. 3.87. What is the ratio of the Imports (in Local Currency Unit) in 1961 in Algeria to that in Australia?
Make the answer very short. 3.08. What is the ratio of the Imports (in Local Currency Unit) in 1962 in Algeria to that in Australia?
Give a very brief answer. 0.92. What is the ratio of the Imports (in Local Currency Unit) in 1963 in Algeria to that in Australia?
Your answer should be compact. 1.85. What is the ratio of the Imports (in Local Currency Unit) in 1960 in Algeria to that in Austria?
Offer a terse response. 3.12. What is the ratio of the Imports (in Local Currency Unit) in 1961 in Algeria to that in Austria?
Keep it short and to the point. 2.68. What is the ratio of the Imports (in Local Currency Unit) in 1962 in Algeria to that in Austria?
Your answer should be compact. 0.63. What is the ratio of the Imports (in Local Currency Unit) in 1963 in Algeria to that in Austria?
Give a very brief answer. 1.36. What is the ratio of the Imports (in Local Currency Unit) in 1960 in Algeria to that in Bangladesh?
Provide a succinct answer. 4.73. What is the ratio of the Imports (in Local Currency Unit) in 1961 in Algeria to that in Bangladesh?
Your answer should be compact. 3. What is the ratio of the Imports (in Local Currency Unit) in 1962 in Algeria to that in Bangladesh?
Give a very brief answer. 0.78. What is the ratio of the Imports (in Local Currency Unit) in 1963 in Algeria to that in Bangladesh?
Offer a very short reply. 1.65. What is the ratio of the Imports (in Local Currency Unit) of 1960 in Algeria to that in Belgium?
Offer a terse response. 1.62. What is the ratio of the Imports (in Local Currency Unit) in 1961 in Algeria to that in Belgium?
Provide a short and direct response. 1.33. What is the ratio of the Imports (in Local Currency Unit) in 1962 in Algeria to that in Belgium?
Your answer should be compact. 0.31. What is the ratio of the Imports (in Local Currency Unit) of 1963 in Algeria to that in Belgium?
Ensure brevity in your answer.  0.65. What is the ratio of the Imports (in Local Currency Unit) of 1963 in Argentina to that in Australia?
Offer a terse response. 0. What is the ratio of the Imports (in Local Currency Unit) of 1961 in Argentina to that in Austria?
Offer a very short reply. 0. What is the ratio of the Imports (in Local Currency Unit) in 1962 in Argentina to that in Austria?
Keep it short and to the point. 0. What is the ratio of the Imports (in Local Currency Unit) of 1960 in Argentina to that in Bangladesh?
Your response must be concise. 0. What is the ratio of the Imports (in Local Currency Unit) of 1963 in Argentina to that in Bangladesh?
Provide a short and direct response. 0. What is the ratio of the Imports (in Local Currency Unit) in 1961 in Argentina to that in Belgium?
Your answer should be very brief. 0. What is the ratio of the Imports (in Local Currency Unit) of 1960 in Australia to that in Austria?
Ensure brevity in your answer.  0.8. What is the ratio of the Imports (in Local Currency Unit) of 1961 in Australia to that in Austria?
Keep it short and to the point. 0.87. What is the ratio of the Imports (in Local Currency Unit) of 1962 in Australia to that in Austria?
Offer a terse response. 0.69. What is the ratio of the Imports (in Local Currency Unit) in 1963 in Australia to that in Austria?
Give a very brief answer. 0.73. What is the ratio of the Imports (in Local Currency Unit) in 1960 in Australia to that in Bangladesh?
Give a very brief answer. 1.22. What is the ratio of the Imports (in Local Currency Unit) in 1961 in Australia to that in Bangladesh?
Make the answer very short. 0.97. What is the ratio of the Imports (in Local Currency Unit) of 1962 in Australia to that in Bangladesh?
Your answer should be compact. 0.85. What is the ratio of the Imports (in Local Currency Unit) of 1963 in Australia to that in Bangladesh?
Offer a terse response. 0.89. What is the ratio of the Imports (in Local Currency Unit) of 1960 in Australia to that in Belgium?
Your response must be concise. 0.42. What is the ratio of the Imports (in Local Currency Unit) of 1961 in Australia to that in Belgium?
Your response must be concise. 0.43. What is the ratio of the Imports (in Local Currency Unit) of 1962 in Australia to that in Belgium?
Ensure brevity in your answer.  0.34. What is the ratio of the Imports (in Local Currency Unit) of 1963 in Australia to that in Belgium?
Your answer should be very brief. 0.35. What is the ratio of the Imports (in Local Currency Unit) in 1960 in Austria to that in Bangladesh?
Your response must be concise. 1.52. What is the ratio of the Imports (in Local Currency Unit) of 1961 in Austria to that in Bangladesh?
Provide a short and direct response. 1.12. What is the ratio of the Imports (in Local Currency Unit) in 1962 in Austria to that in Bangladesh?
Offer a very short reply. 1.23. What is the ratio of the Imports (in Local Currency Unit) in 1963 in Austria to that in Bangladesh?
Your answer should be compact. 1.22. What is the ratio of the Imports (in Local Currency Unit) of 1960 in Austria to that in Belgium?
Your answer should be compact. 0.52. What is the ratio of the Imports (in Local Currency Unit) of 1961 in Austria to that in Belgium?
Offer a very short reply. 0.49. What is the ratio of the Imports (in Local Currency Unit) of 1962 in Austria to that in Belgium?
Your answer should be very brief. 0.49. What is the ratio of the Imports (in Local Currency Unit) of 1963 in Austria to that in Belgium?
Ensure brevity in your answer.  0.48. What is the ratio of the Imports (in Local Currency Unit) in 1960 in Bangladesh to that in Belgium?
Make the answer very short. 0.34. What is the ratio of the Imports (in Local Currency Unit) in 1961 in Bangladesh to that in Belgium?
Provide a short and direct response. 0.44. What is the ratio of the Imports (in Local Currency Unit) of 1962 in Bangladesh to that in Belgium?
Your answer should be very brief. 0.4. What is the ratio of the Imports (in Local Currency Unit) of 1963 in Bangladesh to that in Belgium?
Provide a succinct answer. 0.39. What is the difference between the highest and the second highest Imports (in Local Currency Unit) in 1960?
Offer a terse response. 3.46e+09. What is the difference between the highest and the second highest Imports (in Local Currency Unit) in 1961?
Give a very brief answer. 2.00e+09. What is the difference between the highest and the second highest Imports (in Local Currency Unit) of 1962?
Your response must be concise. 3.42e+09. What is the difference between the highest and the second highest Imports (in Local Currency Unit) in 1963?
Offer a very short reply. 2.63e+09. What is the difference between the highest and the lowest Imports (in Local Currency Unit) in 1960?
Your answer should be compact. 9.03e+09. What is the difference between the highest and the lowest Imports (in Local Currency Unit) in 1961?
Ensure brevity in your answer.  8.11e+09. What is the difference between the highest and the lowest Imports (in Local Currency Unit) in 1962?
Offer a very short reply. 6.67e+09. What is the difference between the highest and the lowest Imports (in Local Currency Unit) of 1963?
Ensure brevity in your answer.  7.54e+09. 